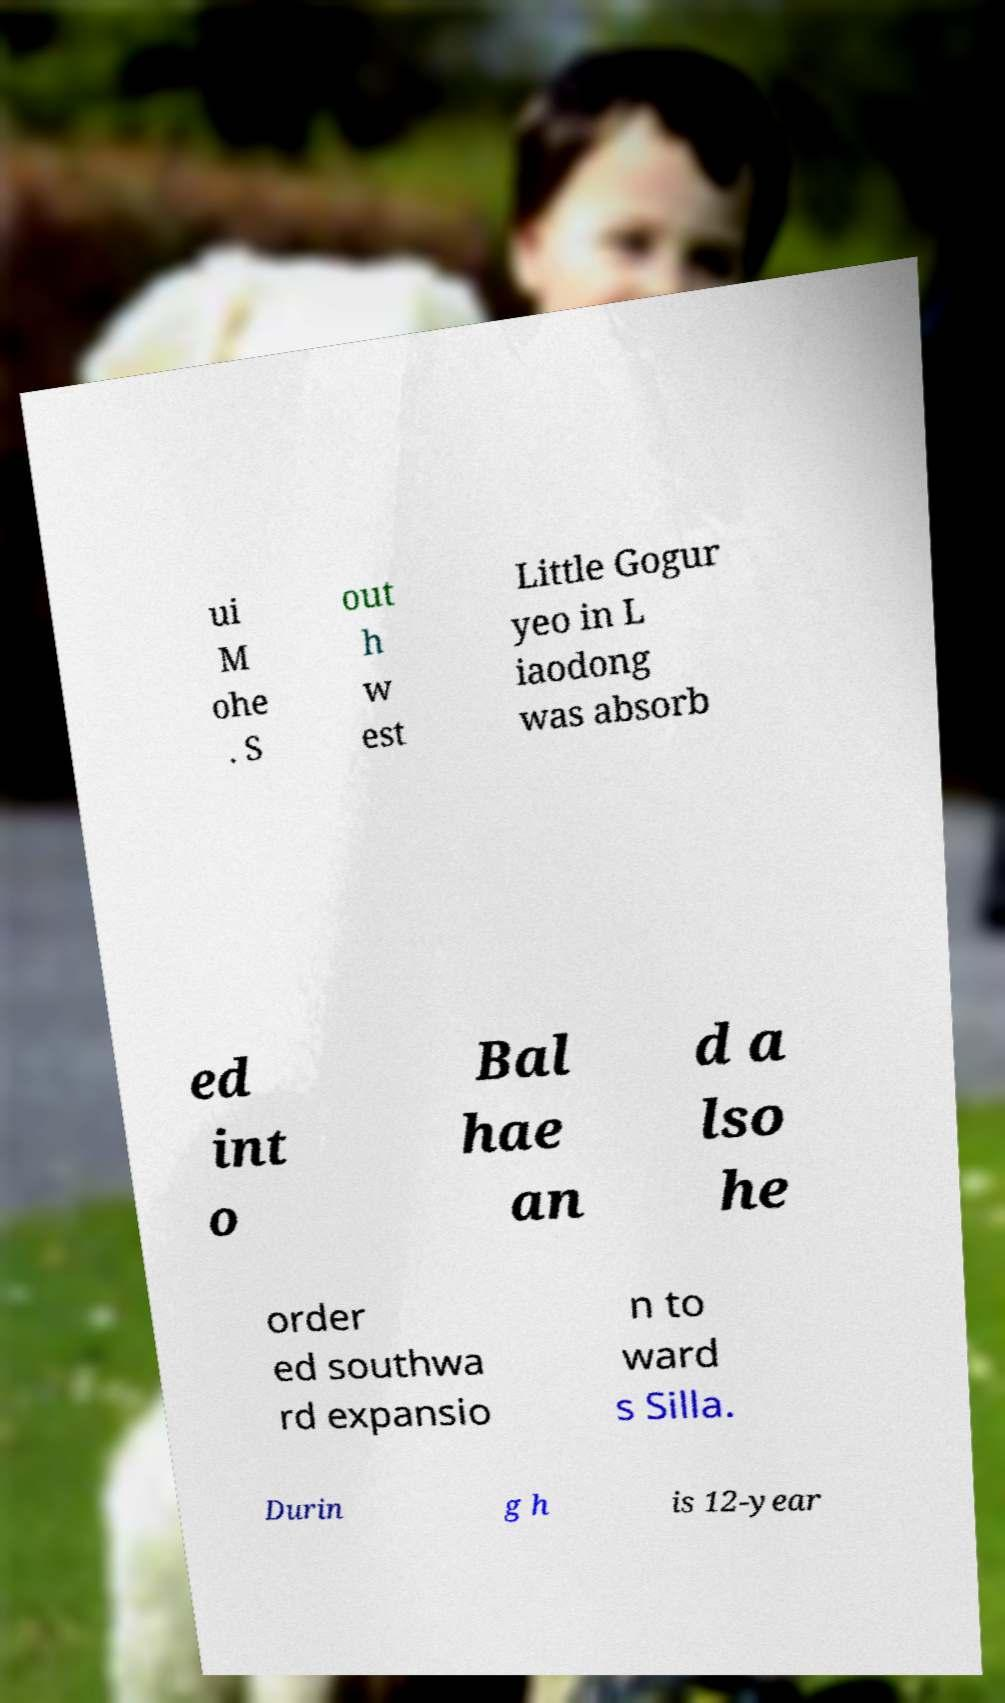For documentation purposes, I need the text within this image transcribed. Could you provide that? ui M ohe . S out h w est Little Gogur yeo in L iaodong was absorb ed int o Bal hae an d a lso he order ed southwa rd expansio n to ward s Silla. Durin g h is 12-year 